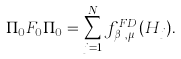<formula> <loc_0><loc_0><loc_500><loc_500>\Pi _ { 0 } F _ { 0 } \Pi _ { 0 } = \sum _ { j = 1 } ^ { N } f _ { \beta _ { j } , \mu _ { j } } ^ { F D } ( H _ { j } ) .</formula> 